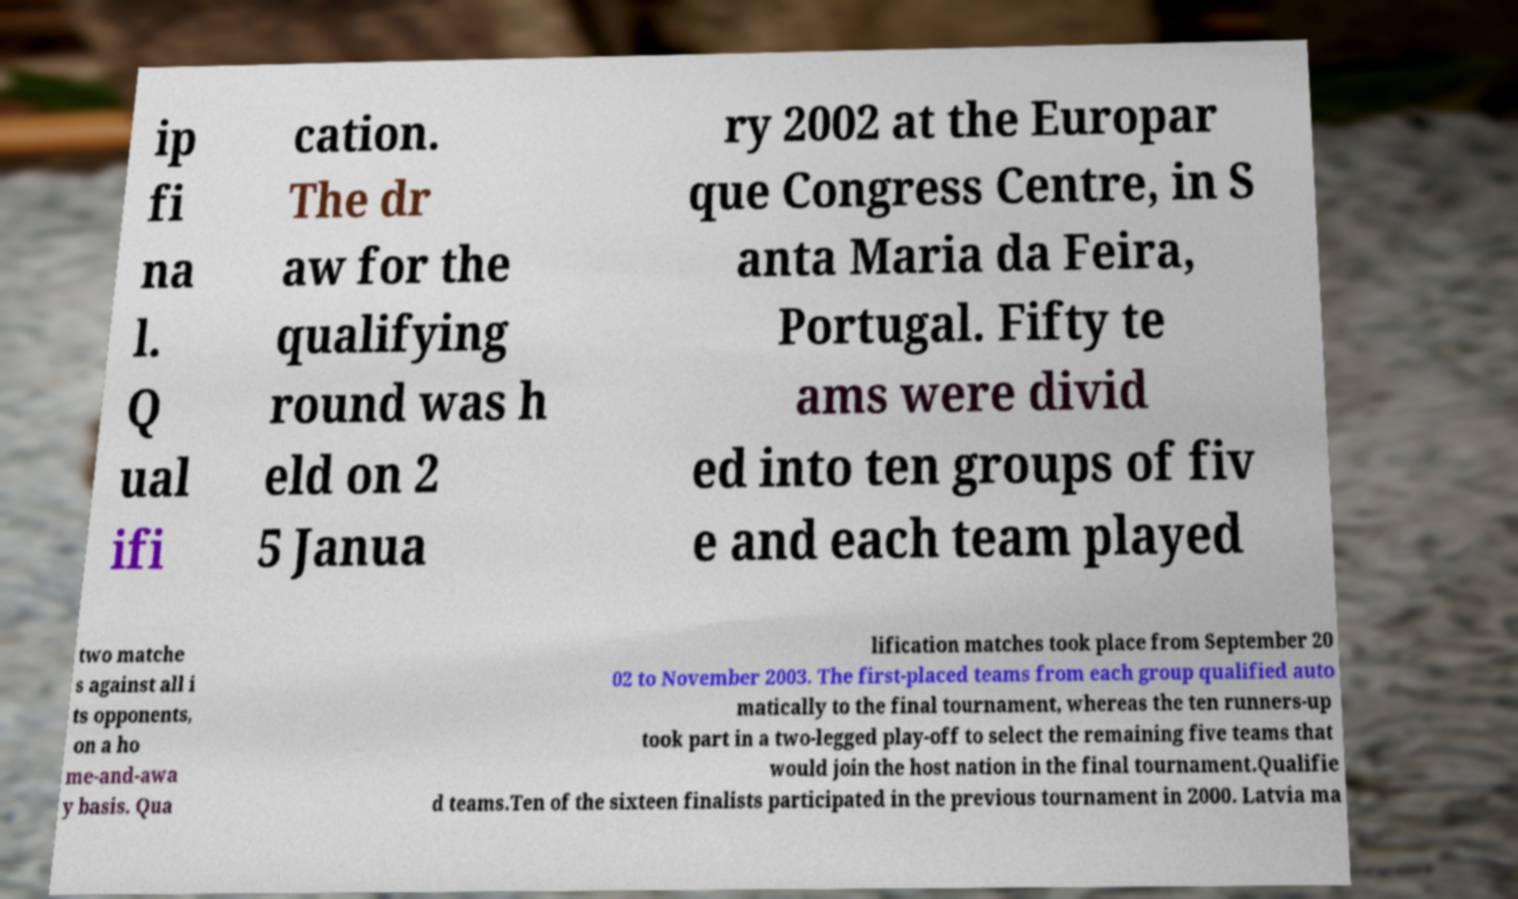Could you extract and type out the text from this image? ip fi na l. Q ual ifi cation. The dr aw for the qualifying round was h eld on 2 5 Janua ry 2002 at the Europar que Congress Centre, in S anta Maria da Feira, Portugal. Fifty te ams were divid ed into ten groups of fiv e and each team played two matche s against all i ts opponents, on a ho me-and-awa y basis. Qua lification matches took place from September 20 02 to November 2003. The first-placed teams from each group qualified auto matically to the final tournament, whereas the ten runners-up took part in a two-legged play-off to select the remaining five teams that would join the host nation in the final tournament.Qualifie d teams.Ten of the sixteen finalists participated in the previous tournament in 2000. Latvia ma 